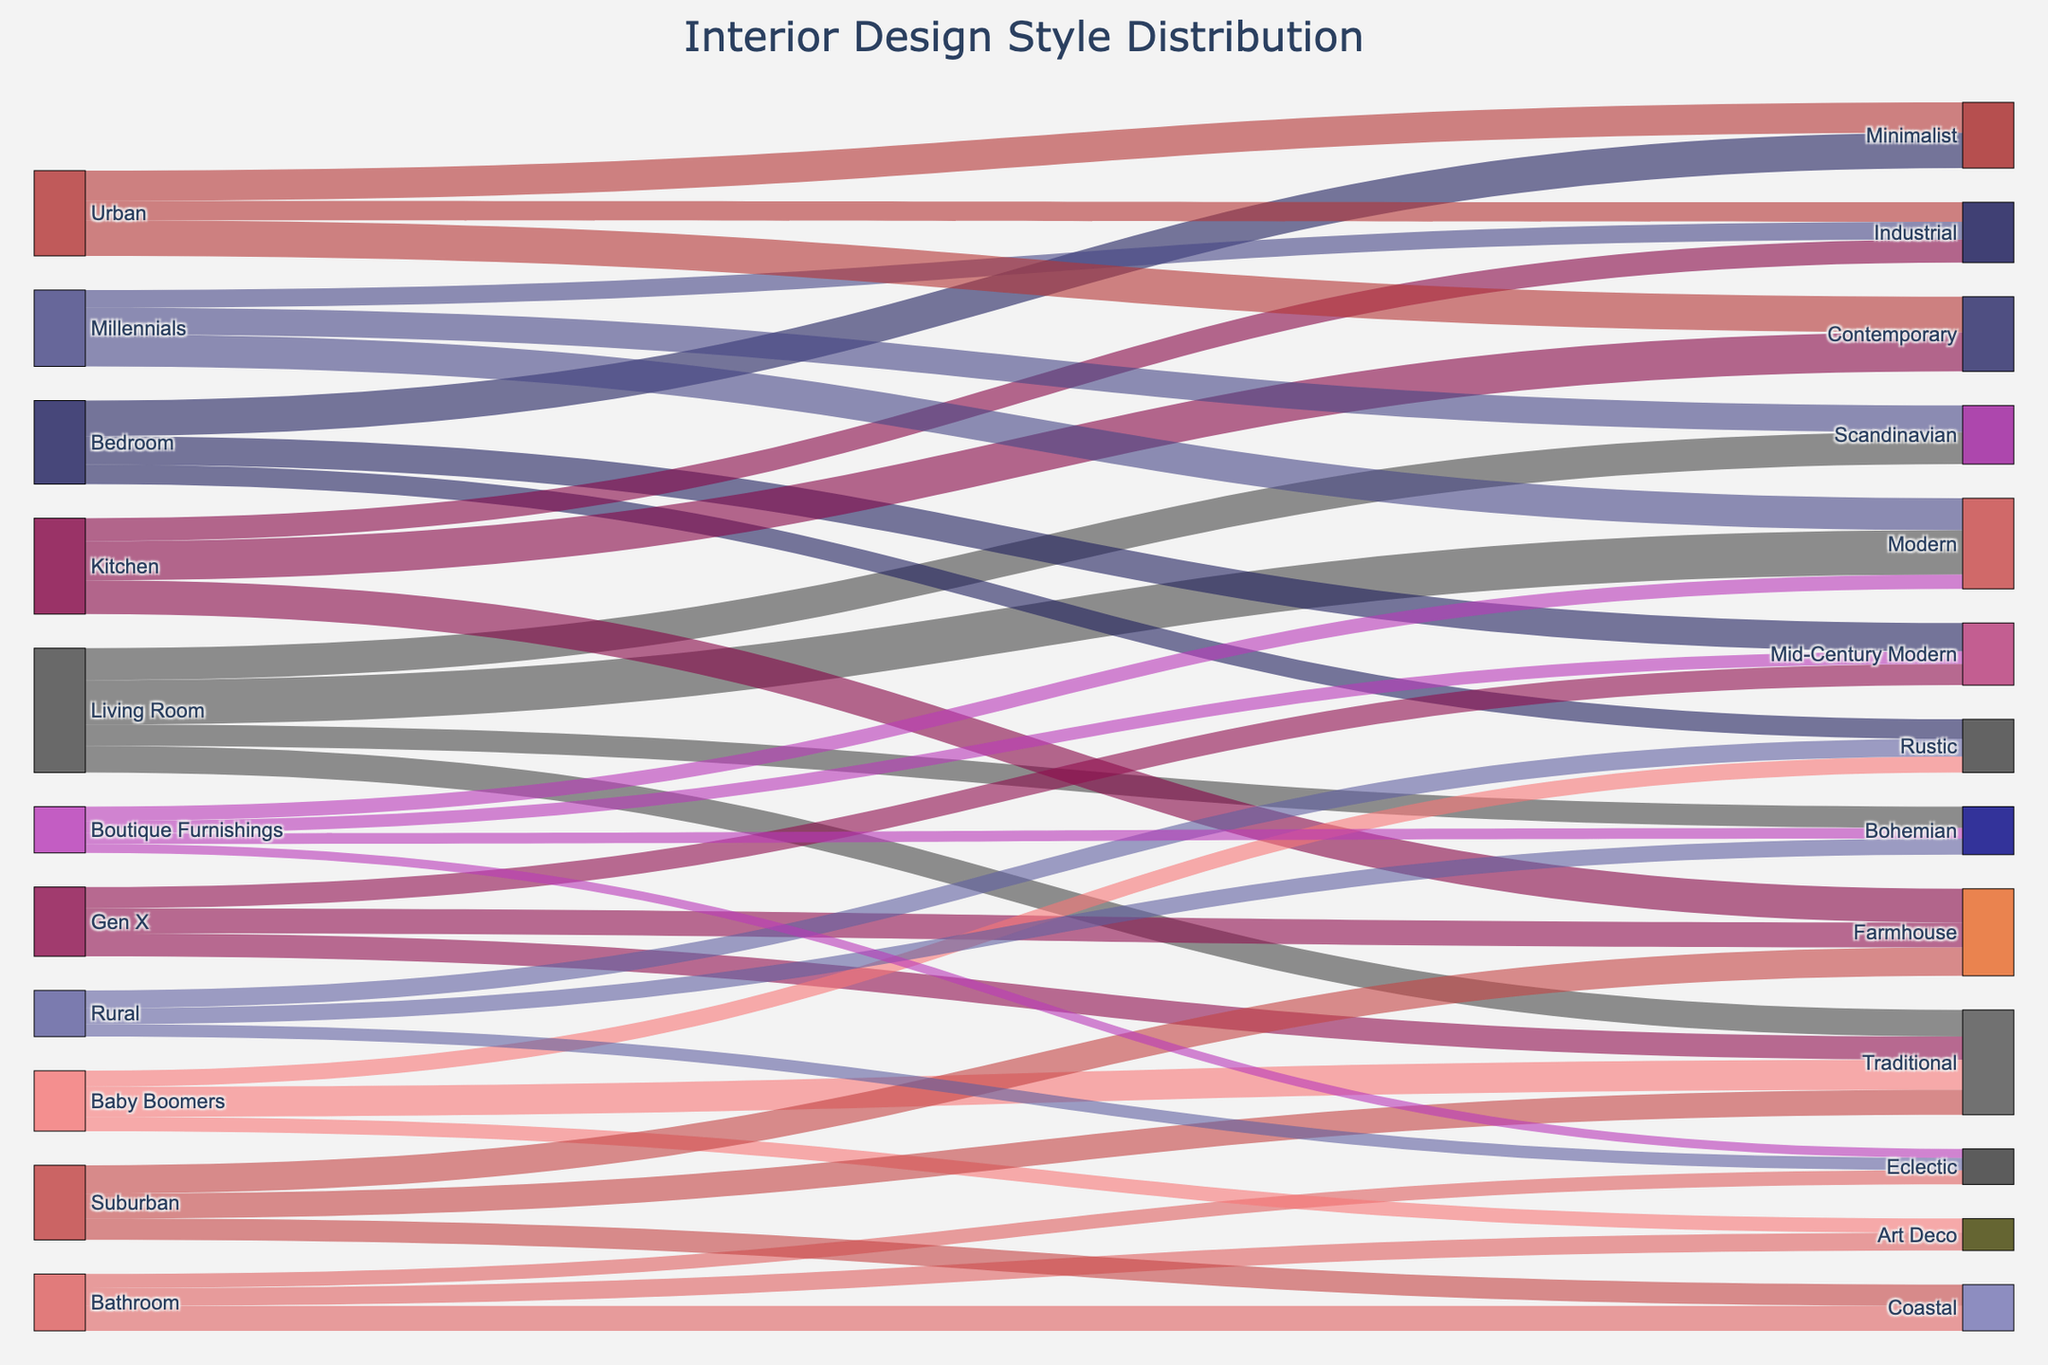What are the four main room types represented in the Sankey diagram? The Sankey diagram shows connections starting from different room types. By examining the sources of all connections, we can identify the four main room types.
Answer: Living Room, Bedroom, Kitchen, Bathroom Which interior design style is most popular among Millennials? Find the demographic "Millennials" and trace the links to see which interior design style it connects to with the highest value.
Answer: Modern How many styles are categorized under the Living Room category? Look at the connections starting from the "Living Room" and count the number of distinct styles it is connected to.
Answer: 4 Which room type has the least variety of design styles chosen? Count the number of unique styles each room type is connected to and identify the one with the fewest connections.
Answer: Bathroom What is the total number of people who chose the Scandinavian style? Sum the values of all connections targeting the Scandinavian style from various sources.
Answer: 330 Compare the popularity of the Modern style between Millennials and Urban demographics. Which demographic prefers it more? Identify the value of connections to the Modern style from both "Millennials" and "Urban" and compare the two values.
Answer: Millennials Which interior design style is unique to the Baby Boomers demographic but not chosen by other demographics? Review the design styles connected to "Baby Boomers" and check if any of these are not connected to other demographics. The unique style doesn't have connections from Millennials or Gen X.
Answer: Art Deco How many people chose styles that align with Boutique Furnishings? Sum the values of the connections starting from "Boutique Furnishings" to various design styles.
Answer: 260 Which interior design style has the highest number of choices from the Suburban demographic? Identify the connections starting from the "Suburban" demographic and find the design style with the highest value.
Answer: Farmhouse Among the Rustic and Bohemian styles, which one is more popular in rural areas? Look at the connections starting from "Rural" to the Rustic and Bohemian styles and compare their values.
Answer: Rustic 